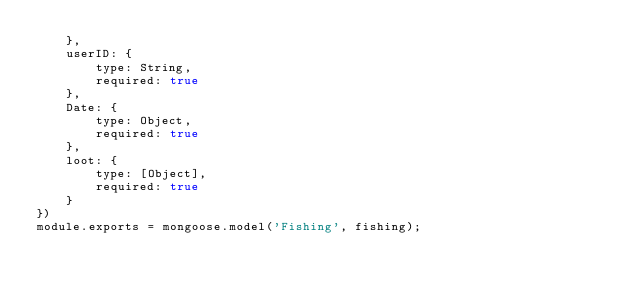Convert code to text. <code><loc_0><loc_0><loc_500><loc_500><_JavaScript_>    },
    userID: {
        type: String,
        required: true
    },
    Date: {
        type: Object,
        required: true
    },
    loot: {
        type: [Object],
        required: true
    }
})
module.exports = mongoose.model('Fishing', fishing);</code> 